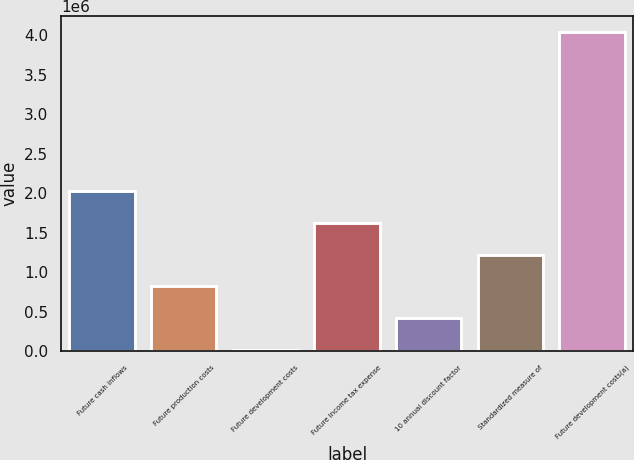<chart> <loc_0><loc_0><loc_500><loc_500><bar_chart><fcel>Future cash inflows<fcel>Future production costs<fcel>Future development costs<fcel>Future income tax expense<fcel>10 annual discount factor<fcel>Standardized measure of<fcel>Future development costs(a)<nl><fcel>2.03024e+06<fcel>821857<fcel>16265<fcel>1.62745e+06<fcel>419061<fcel>1.22465e+06<fcel>4.04422e+06<nl></chart> 